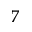<formula> <loc_0><loc_0><loc_500><loc_500>^ { 7 }</formula> 